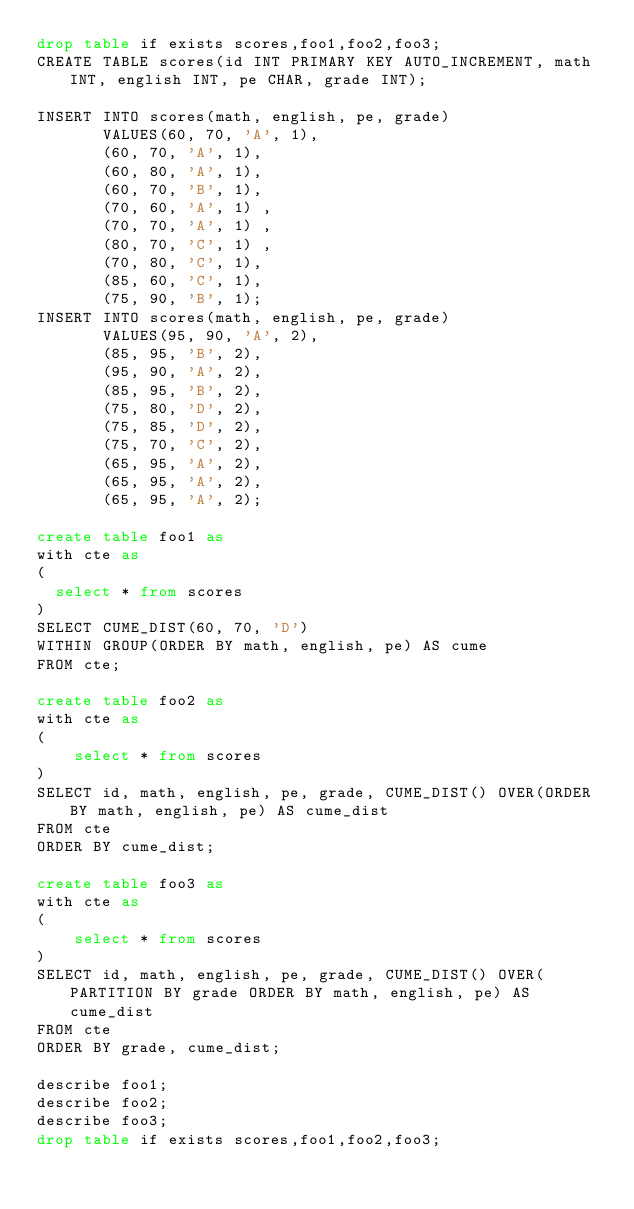Convert code to text. <code><loc_0><loc_0><loc_500><loc_500><_SQL_>drop table if exists scores,foo1,foo2,foo3;
CREATE TABLE scores(id INT PRIMARY KEY AUTO_INCREMENT, math INT, english INT, pe CHAR, grade INT);

INSERT INTO scores(math, english, pe, grade)
       VALUES(60, 70, 'A', 1),
       (60, 70, 'A', 1),
       (60, 80, 'A', 1),
       (60, 70, 'B', 1),
       (70, 60, 'A', 1) ,
       (70, 70, 'A', 1) ,
       (80, 70, 'C', 1) ,
       (70, 80, 'C', 1),
       (85, 60, 'C', 1),
       (75, 90, 'B', 1);
INSERT INTO scores(math, english, pe, grade)
       VALUES(95, 90, 'A', 2),
       (85, 95, 'B', 2),
       (95, 90, 'A', 2),
       (85, 95, 'B', 2),
       (75, 80, 'D', 2),
       (75, 85, 'D', 2),
       (75, 70, 'C', 2),
       (65, 95, 'A', 2),
       (65, 95, 'A', 2),
       (65, 95, 'A', 2);

create table foo1 as
with cte as
(
  select * from scores
)
SELECT CUME_DIST(60, 70, 'D')
WITHIN GROUP(ORDER BY math, english, pe) AS cume
FROM cte;

create table foo2 as
with cte as
(
    select * from scores
)
SELECT id, math, english, pe, grade, CUME_DIST() OVER(ORDER BY math, english, pe) AS cume_dist
FROM cte
ORDER BY cume_dist;

create table foo3 as
with cte as
(
    select * from scores
) 
SELECT id, math, english, pe, grade, CUME_DIST() OVER(PARTITION BY grade ORDER BY math, english, pe) AS cume_dist
FROM cte
ORDER BY grade, cume_dist;

describe foo1;
describe foo2;
describe foo3;
drop table if exists scores,foo1,foo2,foo3;
</code> 